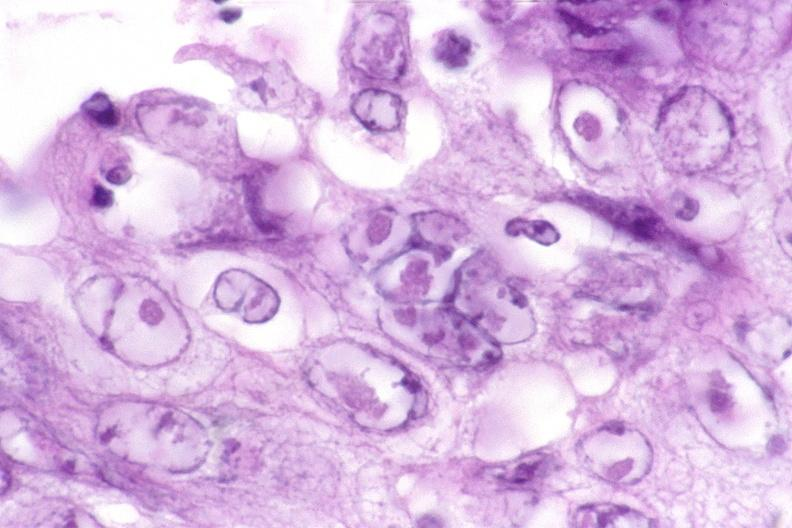what is present?
Answer the question using a single word or phrase. Gastrointestinal 